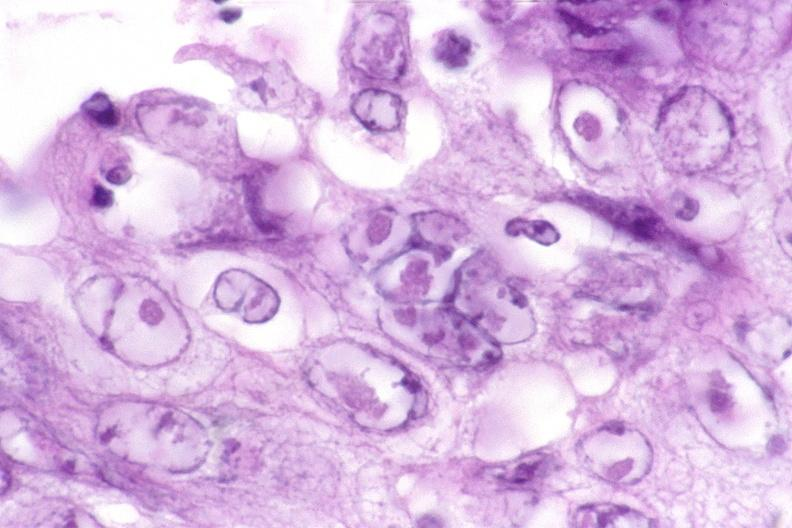what is present?
Answer the question using a single word or phrase. Gastrointestinal 